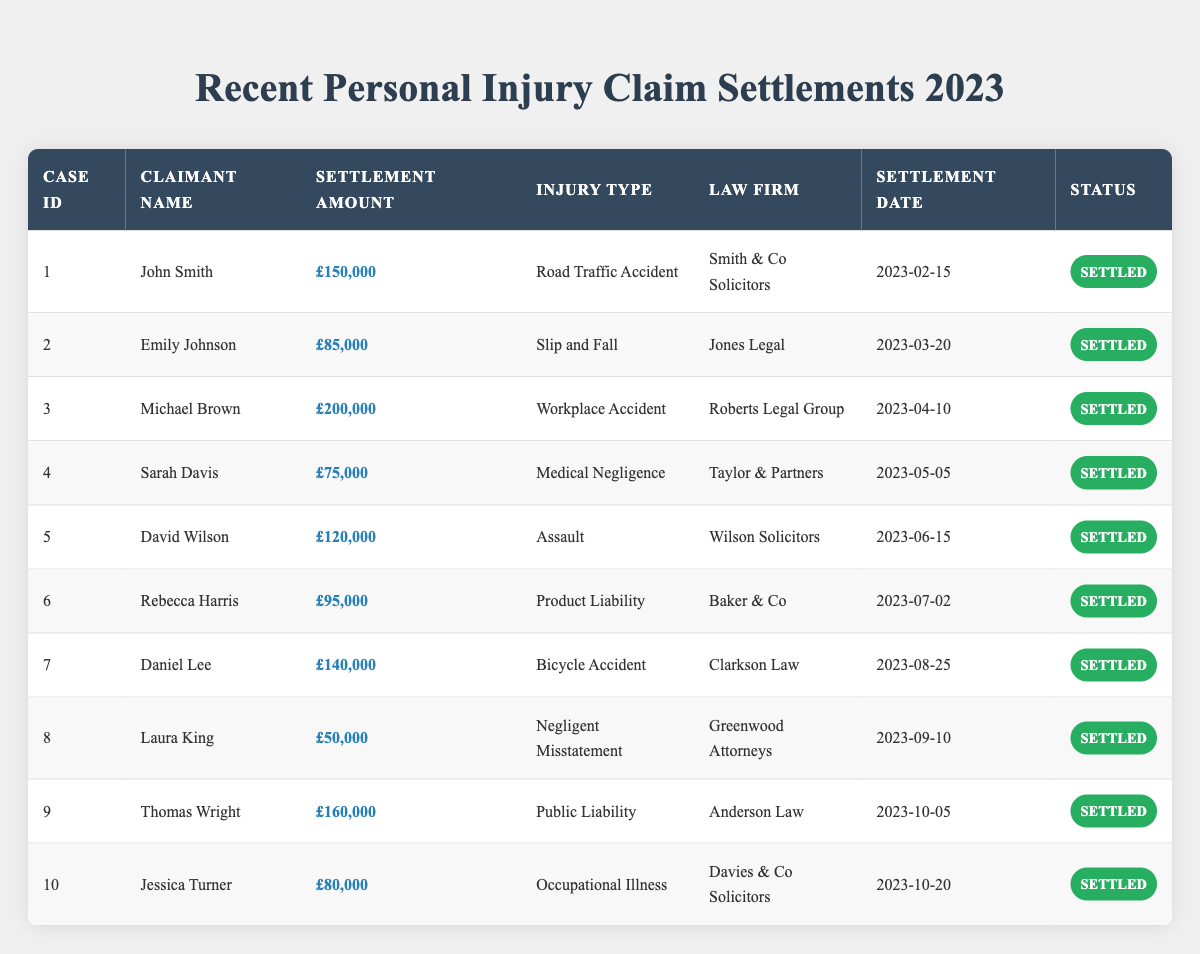What was the highest settlement amount in 2023? By reviewing the settlement amounts, the highest value in the table is £200,000 for Michael Brown's case of Workplace Accident.
Answer: £200,000 Which law firm handled the case with the lowest settlement amount? The case with the lowest settlement amount is £50,000, which was handled by Greenwood Attorneys for Laura King's case of Negligent Misstatement.
Answer: Greenwood Attorneys How many claims were settled for over £100,000? Looking through the table, there are five claims with settlement amounts over £100,000: £150,000, £200,000, £120,000, £140,000, and £160,000.
Answer: 5 What is the total settlement amount for all claims settled in 2023? The total settlement amount is calculated by adding all the settlement values: £150,000 + £85,000 + £200,000 + £75,000 + £120,000 + £95,000 + £140,000 + £50,000 + £160,000 + £80,000 = £1,110,000.
Answer: £1,110,000 Was there any settlement related to Medical Negligence, and what was the amount? Yes, there was a settlement for Medical Negligence by Sarah Davis, which amounted to £75,000.
Answer: Yes, £75,000 Which injury type had the highest settlement amount, and what was that amount? The injury type with the highest settlement amount is Workplace Accident, with a settlement of £200,000 for Michael Brown.
Answer: Workplace Accident, £200,000 How does the average settlement amount compare for cases involving Road Traffic Accidents and Workplace Accidents? The average for Road Traffic Accidents (John Smith, £150,000) is £150,000, and for Workplace Accidents (Michael Brown, £200,000) it is £200,000. Workplace Accident settlements are higher.
Answer: Workplace Accident is higher Is there a case relating to Product Liability? If so, what was the settlement amount? Yes, Rebecca Harris had a case related to Product Liability, with a settlement amount of £95,000.
Answer: Yes, £95,000 What proportion of the total claims had a settlement amount below £100,000? There are 4 claims below £100,000 (£85,000, £75,000, £95,000, £50,000) out of 10 total claims. Therefore, the proportion is 4/10 = 0.4 or 40%.
Answer: 40% If you combine the amounts for Assault and Bicycle Accident claims, what is the total? The Assault claim by David Wilson is £120,000, and the Bicycle Accident claim by Daniel Lee is £140,000. Combining these amounts gives £120,000 + £140,000 = £260,000.
Answer: £260,000 